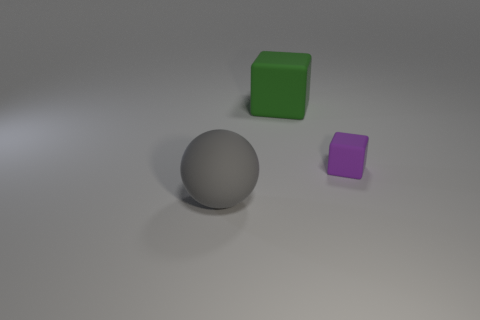Is there anything else that has the same size as the purple rubber thing?
Provide a succinct answer. No. What is the shape of the big gray rubber thing?
Make the answer very short. Sphere. There is another object that is the same shape as the tiny matte thing; what is it made of?
Make the answer very short. Rubber. How many other red balls have the same size as the ball?
Offer a very short reply. 0. Is there a small purple matte thing that is to the left of the large matte object to the right of the gray ball?
Give a very brief answer. No. How many gray objects are big rubber blocks or tiny blocks?
Offer a very short reply. 0. What color is the sphere?
Give a very brief answer. Gray. What is the size of the cube that is the same material as the big green object?
Keep it short and to the point. Small. What number of other green matte things have the same shape as the small object?
Provide a succinct answer. 1. There is a rubber block on the right side of the block that is left of the small purple block; what size is it?
Keep it short and to the point. Small. 